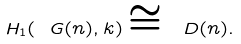Convert formula to latex. <formula><loc_0><loc_0><loc_500><loc_500>H _ { 1 } ( \ G ( n ) , { k } ) \cong \ D ( n ) .</formula> 